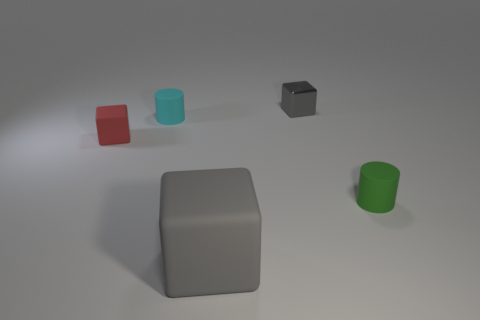Add 5 large gray rubber spheres. How many objects exist? 10 Add 3 rubber things. How many rubber things are left? 7 Add 3 large matte blocks. How many large matte blocks exist? 4 Subtract all red blocks. How many blocks are left? 2 Subtract all tiny blocks. How many blocks are left? 1 Subtract 1 red blocks. How many objects are left? 4 Subtract all cylinders. How many objects are left? 3 Subtract 1 cubes. How many cubes are left? 2 Subtract all green cubes. Subtract all gray spheres. How many cubes are left? 3 Subtract all gray blocks. How many green cylinders are left? 1 